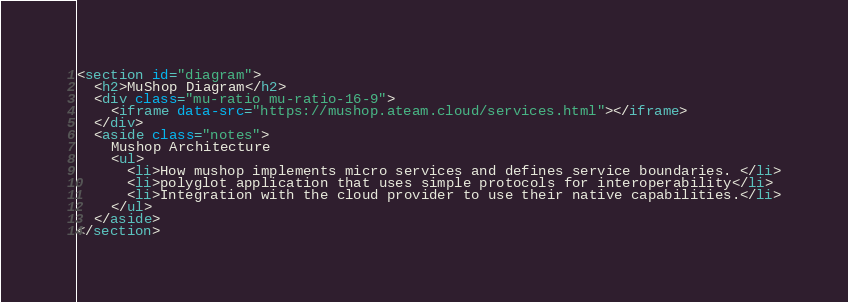<code> <loc_0><loc_0><loc_500><loc_500><_HTML_><section id="diagram">
  <h2>MuShop Diagram</h2>
  <div class="mu-ratio mu-ratio-16-9">
    <iframe data-src="https://mushop.ateam.cloud/services.html"></iframe>
  </div>
  <aside class="notes">
    Mushop Architecture
    <ul>
      <li>How mushop implements micro services and defines service boundaries. </li>
      <li>polyglot application that uses simple protocols for interoperability</li>
      <li>Integration with the cloud provider to use their native capabilities.</li>
    </ul>
  </aside>
</section>
</code> 